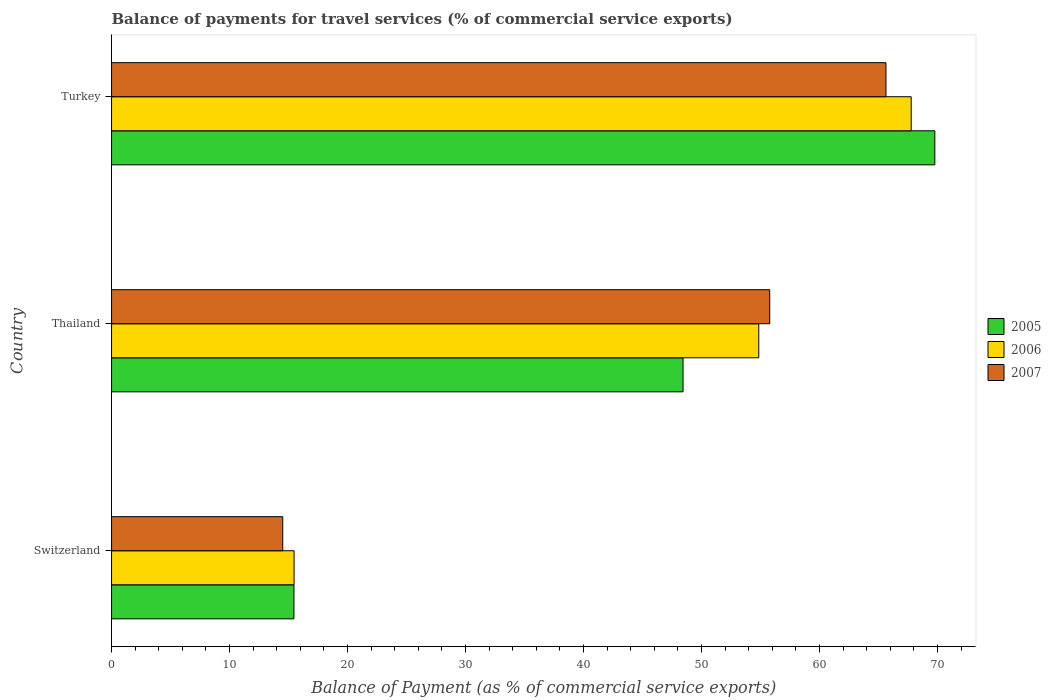How many groups of bars are there?
Provide a short and direct response. 3. Are the number of bars per tick equal to the number of legend labels?
Give a very brief answer. Yes. Are the number of bars on each tick of the Y-axis equal?
Provide a short and direct response. Yes. How many bars are there on the 1st tick from the top?
Provide a short and direct response. 3. What is the label of the 3rd group of bars from the top?
Offer a terse response. Switzerland. In how many cases, is the number of bars for a given country not equal to the number of legend labels?
Offer a terse response. 0. What is the balance of payments for travel services in 2007 in Turkey?
Make the answer very short. 65.64. Across all countries, what is the maximum balance of payments for travel services in 2005?
Keep it short and to the point. 69.78. Across all countries, what is the minimum balance of payments for travel services in 2005?
Offer a terse response. 15.46. In which country was the balance of payments for travel services in 2005 minimum?
Offer a terse response. Switzerland. What is the total balance of payments for travel services in 2005 in the graph?
Make the answer very short. 133.68. What is the difference between the balance of payments for travel services in 2006 in Switzerland and that in Thailand?
Your answer should be very brief. -39.39. What is the difference between the balance of payments for travel services in 2006 in Thailand and the balance of payments for travel services in 2005 in Switzerland?
Your response must be concise. 39.4. What is the average balance of payments for travel services in 2006 per country?
Your response must be concise. 46.04. What is the difference between the balance of payments for travel services in 2006 and balance of payments for travel services in 2005 in Turkey?
Ensure brevity in your answer.  -2. In how many countries, is the balance of payments for travel services in 2007 greater than 8 %?
Give a very brief answer. 3. What is the ratio of the balance of payments for travel services in 2007 in Switzerland to that in Thailand?
Provide a short and direct response. 0.26. Is the balance of payments for travel services in 2005 in Switzerland less than that in Thailand?
Your response must be concise. Yes. What is the difference between the highest and the second highest balance of payments for travel services in 2006?
Keep it short and to the point. 12.92. What is the difference between the highest and the lowest balance of payments for travel services in 2005?
Ensure brevity in your answer.  54.32. Is the sum of the balance of payments for travel services in 2006 in Thailand and Turkey greater than the maximum balance of payments for travel services in 2007 across all countries?
Offer a terse response. Yes. Are all the bars in the graph horizontal?
Make the answer very short. Yes. What is the difference between two consecutive major ticks on the X-axis?
Ensure brevity in your answer.  10. Are the values on the major ticks of X-axis written in scientific E-notation?
Offer a terse response. No. Where does the legend appear in the graph?
Provide a succinct answer. Center right. What is the title of the graph?
Your response must be concise. Balance of payments for travel services (% of commercial service exports). What is the label or title of the X-axis?
Your response must be concise. Balance of Payment (as % of commercial service exports). What is the label or title of the Y-axis?
Your response must be concise. Country. What is the Balance of Payment (as % of commercial service exports) of 2005 in Switzerland?
Keep it short and to the point. 15.46. What is the Balance of Payment (as % of commercial service exports) in 2006 in Switzerland?
Offer a terse response. 15.47. What is the Balance of Payment (as % of commercial service exports) in 2007 in Switzerland?
Ensure brevity in your answer.  14.51. What is the Balance of Payment (as % of commercial service exports) in 2005 in Thailand?
Ensure brevity in your answer.  48.44. What is the Balance of Payment (as % of commercial service exports) in 2006 in Thailand?
Your answer should be compact. 54.86. What is the Balance of Payment (as % of commercial service exports) in 2007 in Thailand?
Offer a very short reply. 55.79. What is the Balance of Payment (as % of commercial service exports) of 2005 in Turkey?
Offer a very short reply. 69.78. What is the Balance of Payment (as % of commercial service exports) in 2006 in Turkey?
Provide a short and direct response. 67.78. What is the Balance of Payment (as % of commercial service exports) in 2007 in Turkey?
Offer a very short reply. 65.64. Across all countries, what is the maximum Balance of Payment (as % of commercial service exports) in 2005?
Offer a very short reply. 69.78. Across all countries, what is the maximum Balance of Payment (as % of commercial service exports) in 2006?
Make the answer very short. 67.78. Across all countries, what is the maximum Balance of Payment (as % of commercial service exports) of 2007?
Give a very brief answer. 65.64. Across all countries, what is the minimum Balance of Payment (as % of commercial service exports) in 2005?
Your answer should be very brief. 15.46. Across all countries, what is the minimum Balance of Payment (as % of commercial service exports) of 2006?
Provide a succinct answer. 15.47. Across all countries, what is the minimum Balance of Payment (as % of commercial service exports) in 2007?
Make the answer very short. 14.51. What is the total Balance of Payment (as % of commercial service exports) in 2005 in the graph?
Your answer should be very brief. 133.68. What is the total Balance of Payment (as % of commercial service exports) in 2006 in the graph?
Offer a terse response. 138.11. What is the total Balance of Payment (as % of commercial service exports) of 2007 in the graph?
Keep it short and to the point. 135.94. What is the difference between the Balance of Payment (as % of commercial service exports) of 2005 in Switzerland and that in Thailand?
Your answer should be compact. -32.98. What is the difference between the Balance of Payment (as % of commercial service exports) of 2006 in Switzerland and that in Thailand?
Provide a short and direct response. -39.39. What is the difference between the Balance of Payment (as % of commercial service exports) in 2007 in Switzerland and that in Thailand?
Your response must be concise. -41.28. What is the difference between the Balance of Payment (as % of commercial service exports) in 2005 in Switzerland and that in Turkey?
Give a very brief answer. -54.32. What is the difference between the Balance of Payment (as % of commercial service exports) in 2006 in Switzerland and that in Turkey?
Offer a terse response. -52.31. What is the difference between the Balance of Payment (as % of commercial service exports) in 2007 in Switzerland and that in Turkey?
Your response must be concise. -51.13. What is the difference between the Balance of Payment (as % of commercial service exports) in 2005 in Thailand and that in Turkey?
Offer a very short reply. -21.34. What is the difference between the Balance of Payment (as % of commercial service exports) of 2006 in Thailand and that in Turkey?
Give a very brief answer. -12.92. What is the difference between the Balance of Payment (as % of commercial service exports) in 2007 in Thailand and that in Turkey?
Offer a terse response. -9.85. What is the difference between the Balance of Payment (as % of commercial service exports) in 2005 in Switzerland and the Balance of Payment (as % of commercial service exports) in 2006 in Thailand?
Ensure brevity in your answer.  -39.4. What is the difference between the Balance of Payment (as % of commercial service exports) of 2005 in Switzerland and the Balance of Payment (as % of commercial service exports) of 2007 in Thailand?
Make the answer very short. -40.33. What is the difference between the Balance of Payment (as % of commercial service exports) in 2006 in Switzerland and the Balance of Payment (as % of commercial service exports) in 2007 in Thailand?
Your answer should be compact. -40.31. What is the difference between the Balance of Payment (as % of commercial service exports) of 2005 in Switzerland and the Balance of Payment (as % of commercial service exports) of 2006 in Turkey?
Ensure brevity in your answer.  -52.32. What is the difference between the Balance of Payment (as % of commercial service exports) of 2005 in Switzerland and the Balance of Payment (as % of commercial service exports) of 2007 in Turkey?
Ensure brevity in your answer.  -50.18. What is the difference between the Balance of Payment (as % of commercial service exports) in 2006 in Switzerland and the Balance of Payment (as % of commercial service exports) in 2007 in Turkey?
Provide a succinct answer. -50.17. What is the difference between the Balance of Payment (as % of commercial service exports) in 2005 in Thailand and the Balance of Payment (as % of commercial service exports) in 2006 in Turkey?
Give a very brief answer. -19.34. What is the difference between the Balance of Payment (as % of commercial service exports) in 2005 in Thailand and the Balance of Payment (as % of commercial service exports) in 2007 in Turkey?
Your answer should be compact. -17.2. What is the difference between the Balance of Payment (as % of commercial service exports) of 2006 in Thailand and the Balance of Payment (as % of commercial service exports) of 2007 in Turkey?
Provide a short and direct response. -10.78. What is the average Balance of Payment (as % of commercial service exports) of 2005 per country?
Offer a terse response. 44.56. What is the average Balance of Payment (as % of commercial service exports) of 2006 per country?
Give a very brief answer. 46.04. What is the average Balance of Payment (as % of commercial service exports) of 2007 per country?
Give a very brief answer. 45.31. What is the difference between the Balance of Payment (as % of commercial service exports) of 2005 and Balance of Payment (as % of commercial service exports) of 2006 in Switzerland?
Ensure brevity in your answer.  -0.01. What is the difference between the Balance of Payment (as % of commercial service exports) in 2005 and Balance of Payment (as % of commercial service exports) in 2007 in Switzerland?
Ensure brevity in your answer.  0.95. What is the difference between the Balance of Payment (as % of commercial service exports) of 2006 and Balance of Payment (as % of commercial service exports) of 2007 in Switzerland?
Give a very brief answer. 0.96. What is the difference between the Balance of Payment (as % of commercial service exports) in 2005 and Balance of Payment (as % of commercial service exports) in 2006 in Thailand?
Your response must be concise. -6.42. What is the difference between the Balance of Payment (as % of commercial service exports) of 2005 and Balance of Payment (as % of commercial service exports) of 2007 in Thailand?
Provide a succinct answer. -7.35. What is the difference between the Balance of Payment (as % of commercial service exports) of 2006 and Balance of Payment (as % of commercial service exports) of 2007 in Thailand?
Your response must be concise. -0.93. What is the difference between the Balance of Payment (as % of commercial service exports) in 2005 and Balance of Payment (as % of commercial service exports) in 2006 in Turkey?
Provide a short and direct response. 2. What is the difference between the Balance of Payment (as % of commercial service exports) in 2005 and Balance of Payment (as % of commercial service exports) in 2007 in Turkey?
Offer a terse response. 4.14. What is the difference between the Balance of Payment (as % of commercial service exports) of 2006 and Balance of Payment (as % of commercial service exports) of 2007 in Turkey?
Give a very brief answer. 2.14. What is the ratio of the Balance of Payment (as % of commercial service exports) in 2005 in Switzerland to that in Thailand?
Make the answer very short. 0.32. What is the ratio of the Balance of Payment (as % of commercial service exports) of 2006 in Switzerland to that in Thailand?
Provide a short and direct response. 0.28. What is the ratio of the Balance of Payment (as % of commercial service exports) of 2007 in Switzerland to that in Thailand?
Provide a short and direct response. 0.26. What is the ratio of the Balance of Payment (as % of commercial service exports) of 2005 in Switzerland to that in Turkey?
Give a very brief answer. 0.22. What is the ratio of the Balance of Payment (as % of commercial service exports) of 2006 in Switzerland to that in Turkey?
Your response must be concise. 0.23. What is the ratio of the Balance of Payment (as % of commercial service exports) of 2007 in Switzerland to that in Turkey?
Your response must be concise. 0.22. What is the ratio of the Balance of Payment (as % of commercial service exports) in 2005 in Thailand to that in Turkey?
Keep it short and to the point. 0.69. What is the ratio of the Balance of Payment (as % of commercial service exports) in 2006 in Thailand to that in Turkey?
Keep it short and to the point. 0.81. What is the ratio of the Balance of Payment (as % of commercial service exports) of 2007 in Thailand to that in Turkey?
Offer a terse response. 0.85. What is the difference between the highest and the second highest Balance of Payment (as % of commercial service exports) in 2005?
Provide a short and direct response. 21.34. What is the difference between the highest and the second highest Balance of Payment (as % of commercial service exports) in 2006?
Your answer should be very brief. 12.92. What is the difference between the highest and the second highest Balance of Payment (as % of commercial service exports) in 2007?
Make the answer very short. 9.85. What is the difference between the highest and the lowest Balance of Payment (as % of commercial service exports) in 2005?
Provide a succinct answer. 54.32. What is the difference between the highest and the lowest Balance of Payment (as % of commercial service exports) in 2006?
Give a very brief answer. 52.31. What is the difference between the highest and the lowest Balance of Payment (as % of commercial service exports) of 2007?
Provide a short and direct response. 51.13. 